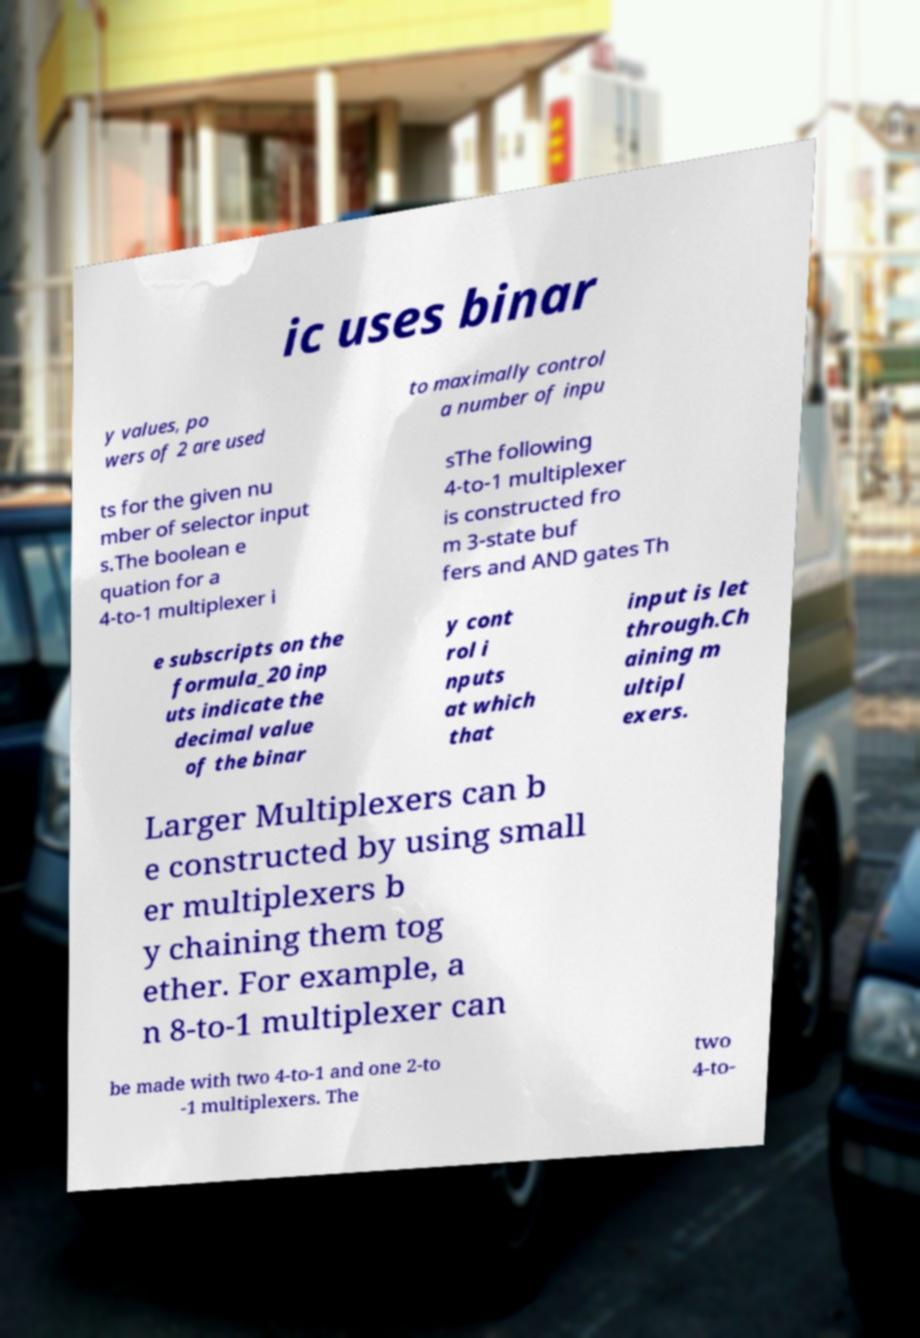Could you assist in decoding the text presented in this image and type it out clearly? ic uses binar y values, po wers of 2 are used to maximally control a number of inpu ts for the given nu mber of selector input s.The boolean e quation for a 4-to-1 multiplexer i sThe following 4-to-1 multiplexer is constructed fro m 3-state buf fers and AND gates Th e subscripts on the formula_20 inp uts indicate the decimal value of the binar y cont rol i nputs at which that input is let through.Ch aining m ultipl exers. Larger Multiplexers can b e constructed by using small er multiplexers b y chaining them tog ether. For example, a n 8-to-1 multiplexer can be made with two 4-to-1 and one 2-to -1 multiplexers. The two 4-to- 